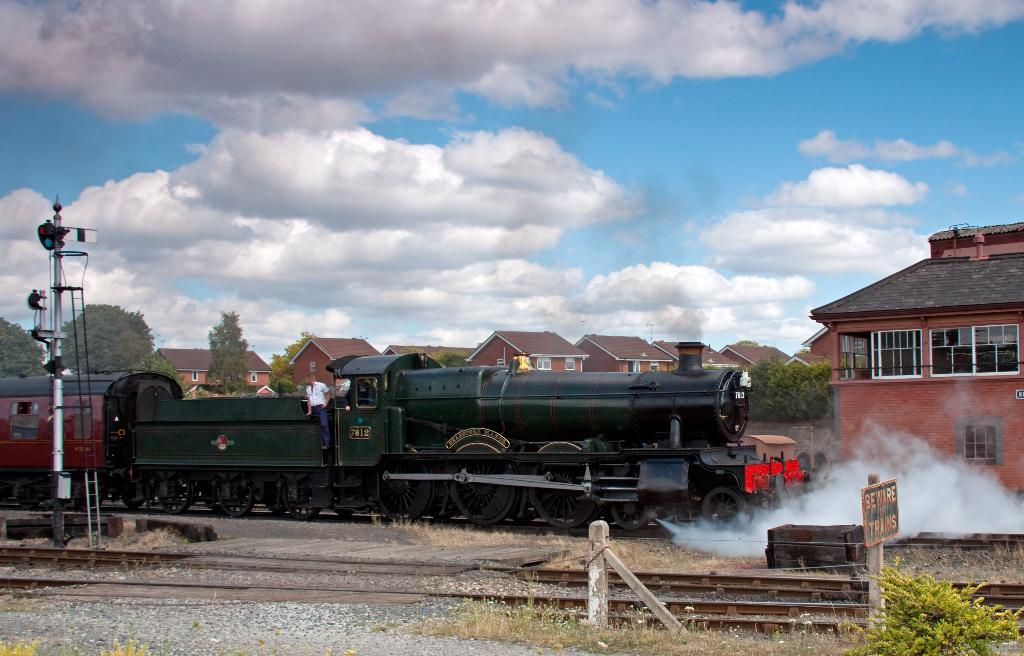What is the main subject of the image? The main subject of the image is a railway track with a train on it. What can be seen in the background of the image? There are houses behind the train. What is located on the left side of the image? There is a pole on the left side of the image. What is the caption of the image? There is no caption present in the image. How much soda is being consumed by the train in the image? There is no soda or consumption of soda depicted in the image. 